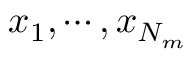Convert formula to latex. <formula><loc_0><loc_0><loc_500><loc_500>x _ { 1 } , \cdots , x _ { N _ { m } }</formula> 